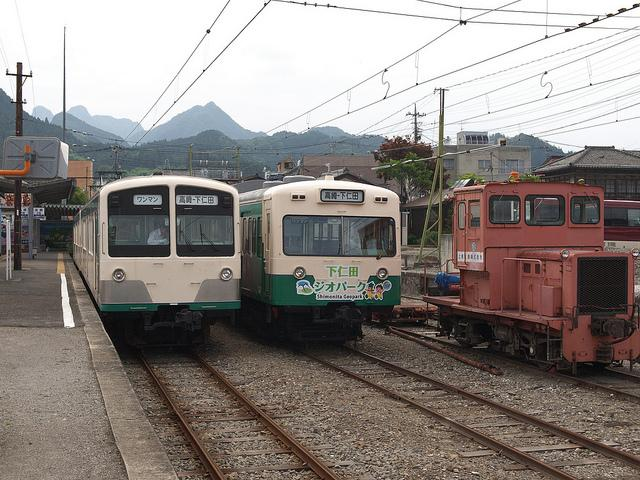What language is mainly spoken here? Please explain your reasoning. japanese. The language depicted is written with symbols common of asian culture, the environment and anime are indicators of which asian culture. 